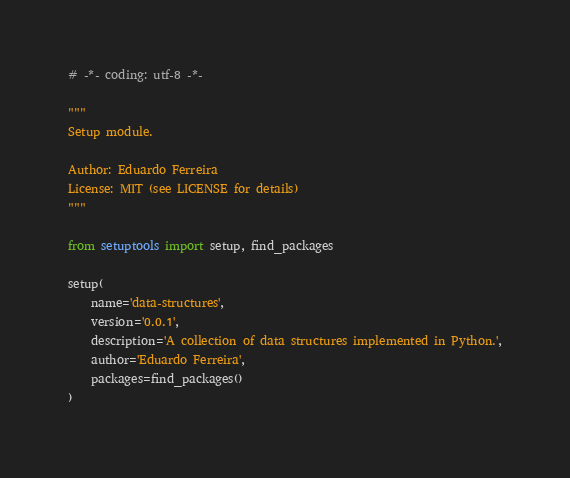Convert code to text. <code><loc_0><loc_0><loc_500><loc_500><_Python_># -*- coding: utf-8 -*-

"""
Setup module.

Author: Eduardo Ferreira
License: MIT (see LICENSE for details)
"""

from setuptools import setup, find_packages

setup(
    name='data-structures',
    version='0.0.1',
    description='A collection of data structures implemented in Python.',
    author='Eduardo Ferreira',
    packages=find_packages()
)
</code> 